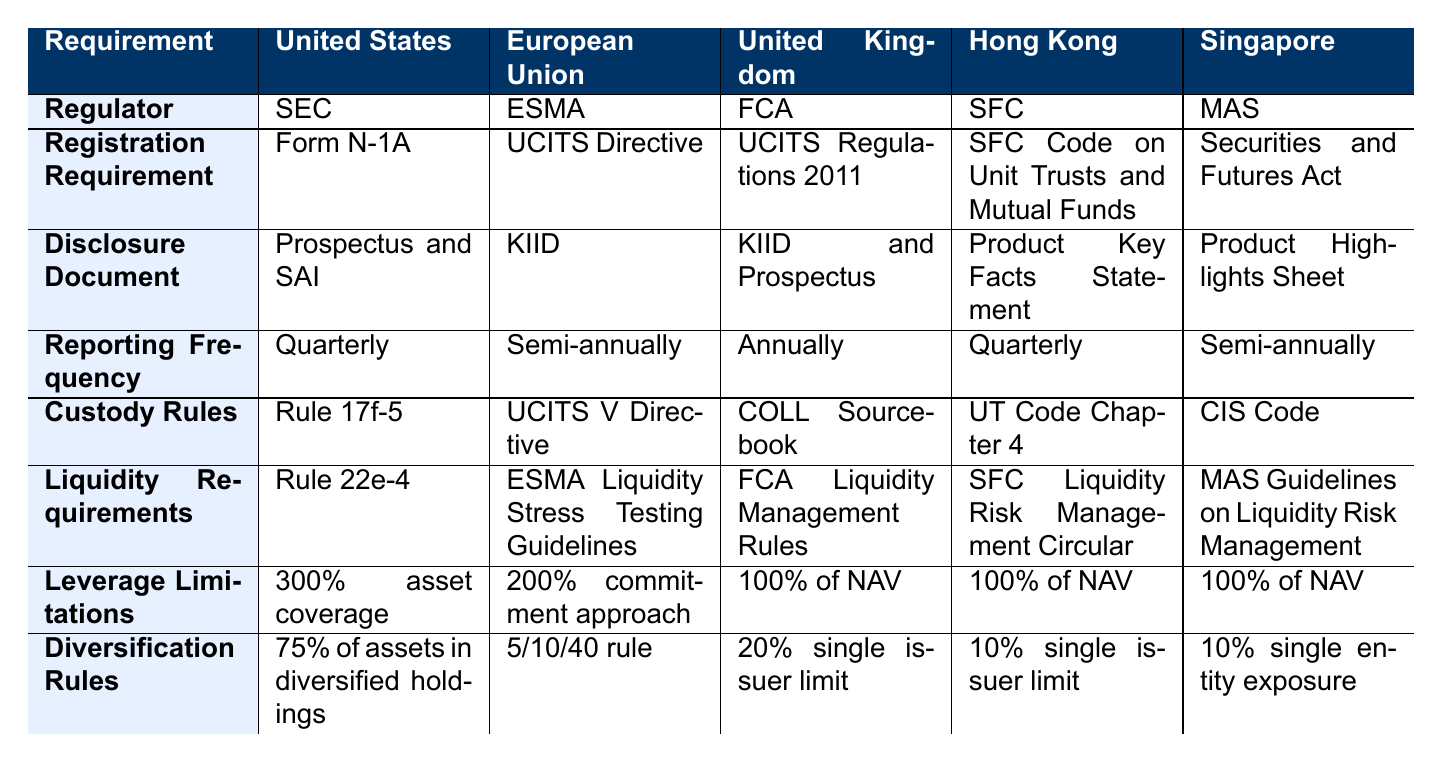What is the registration requirement for ETFs in the United Kingdom? The table lists the registration requirement for the United Kingdom under the "Registration Requirement" row as "UCITS Regulations 2011."
Answer: UCITS Regulations 2011 What is the reporting frequency for ETFs in the European Union? The reporting frequency for the European Union is found in the "Reporting Frequency" row and is noted as "Semi-annually."
Answer: Semi-annually Which market has the strictest leverage limitations for ETFs? By comparing the "Leverage Limitations" for each market: United States (300%), European Union (200%), and others (100%), the United States has the highest leverage limitation at 300% asset coverage.
Answer: United States Do all markets listed have custody rules? Each market has a corresponding custody rule listed under the "Custody Rules" row, confirming that all markets indeed have such provisions.
Answer: Yes What is the difference in reporting frequency between the United Kingdom and Singapore? The United Kingdom has an annual reporting frequency, while Singapore reports semi-annually. The difference is therefore annual (1 year) vs semi-annual (every six months), or a total of 6 months.
Answer: 6 months Which regulator oversees the compliance for ETFs in Hong Kong? Referring to the "Regulator" row, it shows that the SFC (Securities and Futures Commission) oversees ETF compliance in Hong Kong.
Answer: SFC Is the leverage limitation in the European Union higher than in Hong Kong? The European Union has a leverage limitation of 200%, while Hong Kong's limit is 100%. Therefore, 200% is higher than 100%.
Answer: Yes How many different disclosure documents are referenced in the table? The "Disclosure Document" row shows five different documents for five markets. Each market has a unique or shared document.
Answer: 5 What is the lowest single issuer limit for diversification rules among the listed markets? The table lists the following diversification rules: United Kingdom (20%), Hong Kong (10%), and Singapore (10%). The lowest is 10%, which is shared by Hong Kong and Singapore.
Answer: 10% Which market requires the most frequent reporting of ETFs? By checking the "Reporting Frequency" row, the United States and Hong Kong both require quarterly reporting, which is more frequent than the others.
Answer: United States and Hong Kong 